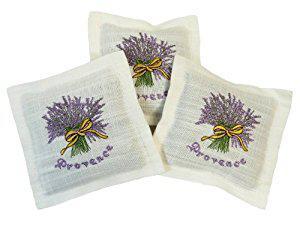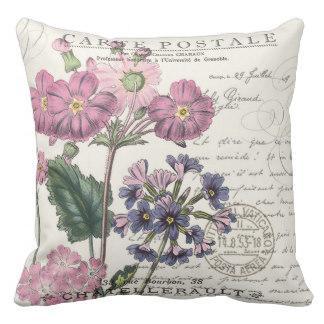The first image is the image on the left, the second image is the image on the right. Examine the images to the left and right. Is the description "At least one of the items contains a image of a lavender plant." accurate? Answer yes or no. Yes. The first image is the image on the left, the second image is the image on the right. For the images shown, is this caption "One image features one square pillow decorated with flowers, and the other image features at least one fabric item decorated with sprigs of lavender." true? Answer yes or no. Yes. 